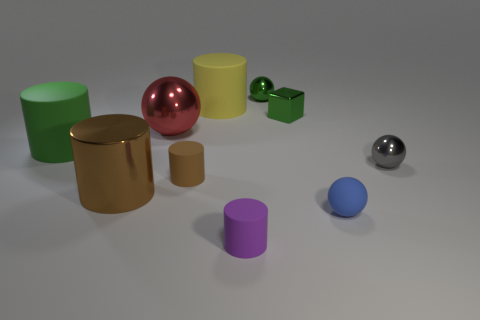Subtract all small gray spheres. How many spheres are left? 3 Subtract all cyan spheres. How many brown cylinders are left? 2 Subtract 2 cylinders. How many cylinders are left? 3 Subtract all yellow cylinders. How many cylinders are left? 4 Subtract all cyan cylinders. Subtract all red cubes. How many cylinders are left? 5 Subtract all spheres. How many objects are left? 6 Add 5 metal balls. How many metal balls are left? 8 Add 5 small blue metal cylinders. How many small blue metal cylinders exist? 5 Subtract 0 blue blocks. How many objects are left? 10 Subtract all metal blocks. Subtract all small spheres. How many objects are left? 6 